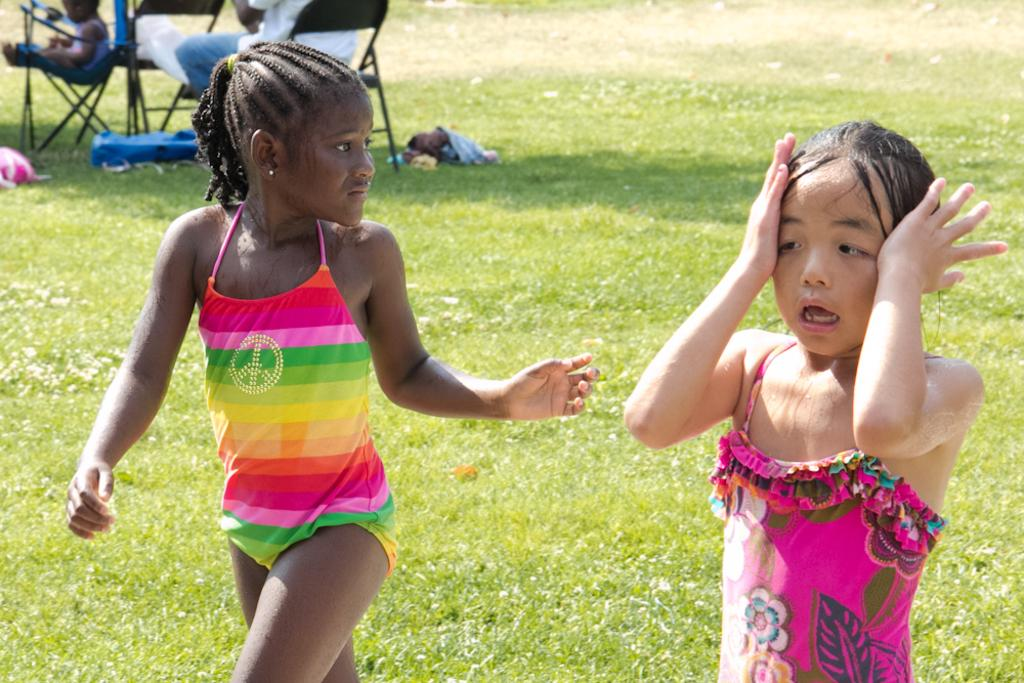How many girls are in the image? There are two girls in the image. What is at the bottom of the image? There is green grass at the bottom of the image. Can you describe the background of the image? In the background of the image, there are two persons sitting in chairs. What type of list can be seen in the ear of one of the girls in the image? There is no list or ear visible in the image; it only features two girls, green grass, and two persons sitting in chairs in the background. 